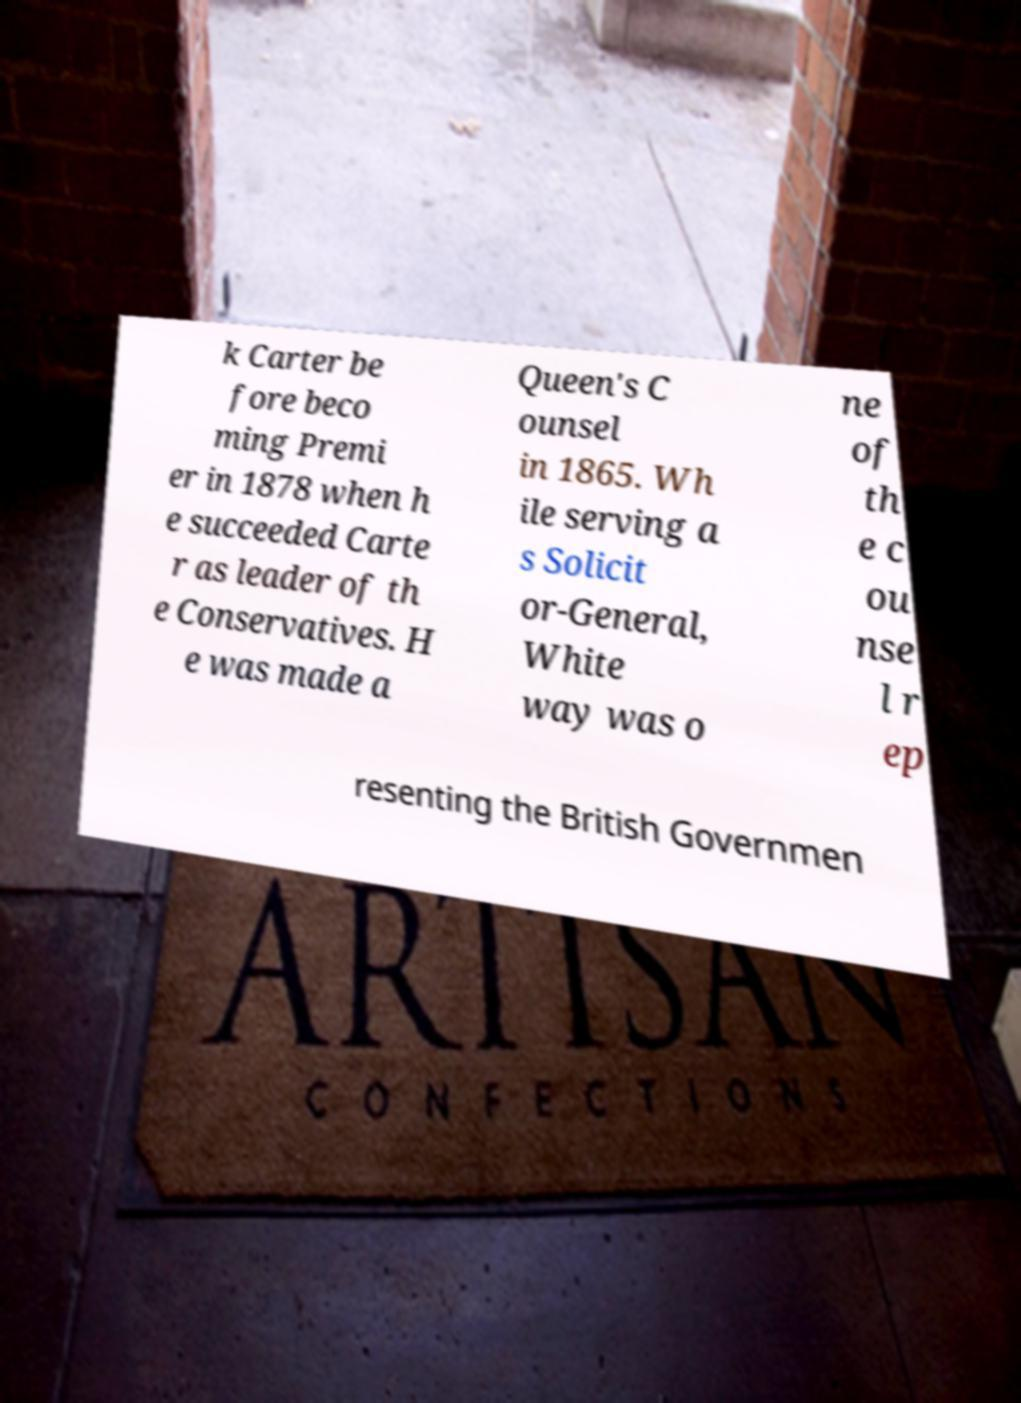Please read and relay the text visible in this image. What does it say? k Carter be fore beco ming Premi er in 1878 when h e succeeded Carte r as leader of th e Conservatives. H e was made a Queen's C ounsel in 1865. Wh ile serving a s Solicit or-General, White way was o ne of th e c ou nse l r ep resenting the British Governmen 